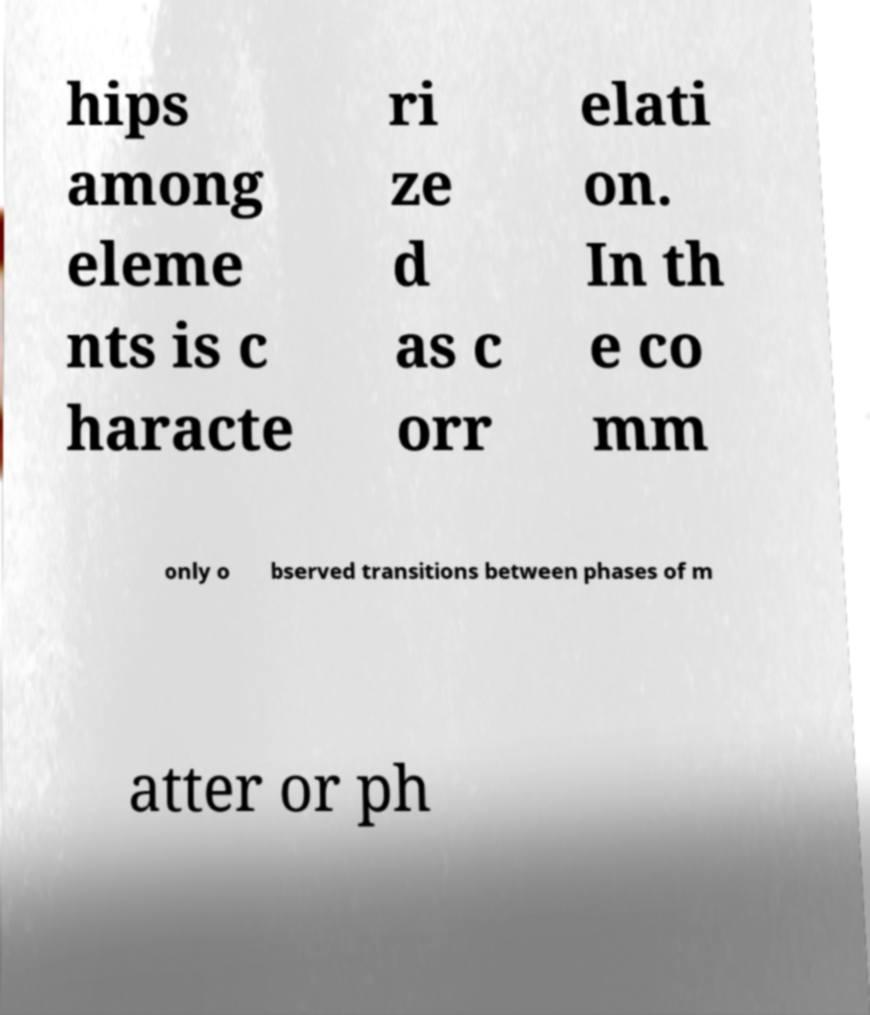Can you accurately transcribe the text from the provided image for me? hips among eleme nts is c haracte ri ze d as c orr elati on. In th e co mm only o bserved transitions between phases of m atter or ph 